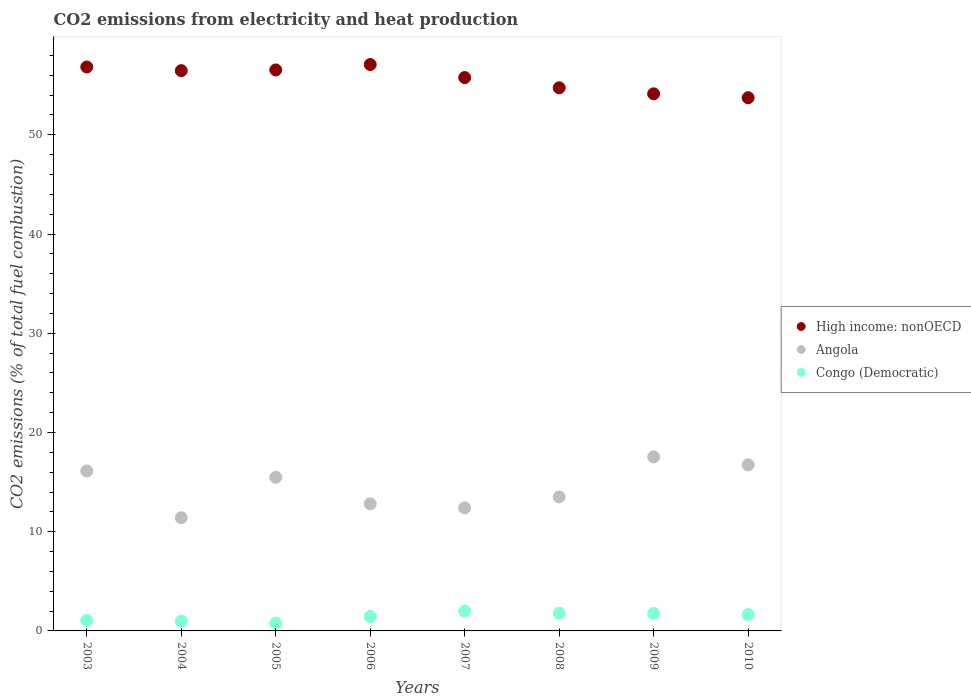How many different coloured dotlines are there?
Give a very brief answer. 3. What is the amount of CO2 emitted in Congo (Democratic) in 2007?
Make the answer very short. 1.99. Across all years, what is the maximum amount of CO2 emitted in High income: nonOECD?
Offer a very short reply. 57.08. Across all years, what is the minimum amount of CO2 emitted in High income: nonOECD?
Give a very brief answer. 53.74. In which year was the amount of CO2 emitted in Angola maximum?
Your response must be concise. 2009. In which year was the amount of CO2 emitted in Congo (Democratic) minimum?
Offer a terse response. 2005. What is the total amount of CO2 emitted in Congo (Democratic) in the graph?
Your response must be concise. 11.47. What is the difference between the amount of CO2 emitted in Angola in 2003 and that in 2009?
Keep it short and to the point. -1.42. What is the difference between the amount of CO2 emitted in Angola in 2006 and the amount of CO2 emitted in Congo (Democratic) in 2010?
Offer a very short reply. 11.17. What is the average amount of CO2 emitted in Angola per year?
Make the answer very short. 14.5. In the year 2009, what is the difference between the amount of CO2 emitted in High income: nonOECD and amount of CO2 emitted in Congo (Democratic)?
Offer a very short reply. 52.37. In how many years, is the amount of CO2 emitted in Angola greater than 22 %?
Offer a very short reply. 0. What is the ratio of the amount of CO2 emitted in Congo (Democratic) in 2006 to that in 2010?
Your answer should be compact. 0.89. What is the difference between the highest and the second highest amount of CO2 emitted in Congo (Democratic)?
Provide a succinct answer. 0.2. What is the difference between the highest and the lowest amount of CO2 emitted in Congo (Democratic)?
Ensure brevity in your answer.  1.21. In how many years, is the amount of CO2 emitted in Congo (Democratic) greater than the average amount of CO2 emitted in Congo (Democratic) taken over all years?
Ensure brevity in your answer.  5. Is it the case that in every year, the sum of the amount of CO2 emitted in High income: nonOECD and amount of CO2 emitted in Congo (Democratic)  is greater than the amount of CO2 emitted in Angola?
Give a very brief answer. Yes. Does the amount of CO2 emitted in Congo (Democratic) monotonically increase over the years?
Give a very brief answer. No. How many dotlines are there?
Ensure brevity in your answer.  3. How many years are there in the graph?
Give a very brief answer. 8. Are the values on the major ticks of Y-axis written in scientific E-notation?
Provide a succinct answer. No. Does the graph contain grids?
Your answer should be very brief. No. Where does the legend appear in the graph?
Your answer should be very brief. Center right. How many legend labels are there?
Make the answer very short. 3. How are the legend labels stacked?
Make the answer very short. Vertical. What is the title of the graph?
Keep it short and to the point. CO2 emissions from electricity and heat production. Does "Greenland" appear as one of the legend labels in the graph?
Offer a terse response. No. What is the label or title of the Y-axis?
Provide a succinct answer. CO2 emissions (% of total fuel combustion). What is the CO2 emissions (% of total fuel combustion) of High income: nonOECD in 2003?
Ensure brevity in your answer.  56.83. What is the CO2 emissions (% of total fuel combustion) of Angola in 2003?
Your answer should be very brief. 16.12. What is the CO2 emissions (% of total fuel combustion) of Congo (Democratic) in 2003?
Offer a terse response. 1.06. What is the CO2 emissions (% of total fuel combustion) in High income: nonOECD in 2004?
Keep it short and to the point. 56.46. What is the CO2 emissions (% of total fuel combustion) in Angola in 2004?
Your answer should be very brief. 11.41. What is the CO2 emissions (% of total fuel combustion) in Congo (Democratic) in 2004?
Give a very brief answer. 0.99. What is the CO2 emissions (% of total fuel combustion) in High income: nonOECD in 2005?
Offer a very short reply. 56.54. What is the CO2 emissions (% of total fuel combustion) of Angola in 2005?
Provide a short and direct response. 15.48. What is the CO2 emissions (% of total fuel combustion) in Congo (Democratic) in 2005?
Provide a succinct answer. 0.78. What is the CO2 emissions (% of total fuel combustion) of High income: nonOECD in 2006?
Provide a succinct answer. 57.08. What is the CO2 emissions (% of total fuel combustion) in Angola in 2006?
Ensure brevity in your answer.  12.81. What is the CO2 emissions (% of total fuel combustion) in Congo (Democratic) in 2006?
Ensure brevity in your answer.  1.46. What is the CO2 emissions (% of total fuel combustion) in High income: nonOECD in 2007?
Keep it short and to the point. 55.77. What is the CO2 emissions (% of total fuel combustion) in Angola in 2007?
Your answer should be compact. 12.4. What is the CO2 emissions (% of total fuel combustion) of Congo (Democratic) in 2007?
Your answer should be very brief. 1.99. What is the CO2 emissions (% of total fuel combustion) of High income: nonOECD in 2008?
Offer a very short reply. 54.74. What is the CO2 emissions (% of total fuel combustion) of Angola in 2008?
Offer a very short reply. 13.51. What is the CO2 emissions (% of total fuel combustion) in Congo (Democratic) in 2008?
Provide a short and direct response. 1.79. What is the CO2 emissions (% of total fuel combustion) in High income: nonOECD in 2009?
Offer a terse response. 54.13. What is the CO2 emissions (% of total fuel combustion) of Angola in 2009?
Offer a very short reply. 17.54. What is the CO2 emissions (% of total fuel combustion) of Congo (Democratic) in 2009?
Give a very brief answer. 1.76. What is the CO2 emissions (% of total fuel combustion) in High income: nonOECD in 2010?
Your answer should be very brief. 53.74. What is the CO2 emissions (% of total fuel combustion) of Angola in 2010?
Keep it short and to the point. 16.74. What is the CO2 emissions (% of total fuel combustion) in Congo (Democratic) in 2010?
Your response must be concise. 1.64. Across all years, what is the maximum CO2 emissions (% of total fuel combustion) of High income: nonOECD?
Provide a short and direct response. 57.08. Across all years, what is the maximum CO2 emissions (% of total fuel combustion) in Angola?
Provide a short and direct response. 17.54. Across all years, what is the maximum CO2 emissions (% of total fuel combustion) of Congo (Democratic)?
Your answer should be very brief. 1.99. Across all years, what is the minimum CO2 emissions (% of total fuel combustion) in High income: nonOECD?
Make the answer very short. 53.74. Across all years, what is the minimum CO2 emissions (% of total fuel combustion) of Angola?
Your response must be concise. 11.41. Across all years, what is the minimum CO2 emissions (% of total fuel combustion) in Congo (Democratic)?
Keep it short and to the point. 0.78. What is the total CO2 emissions (% of total fuel combustion) of High income: nonOECD in the graph?
Your answer should be compact. 445.29. What is the total CO2 emissions (% of total fuel combustion) in Angola in the graph?
Make the answer very short. 116.01. What is the total CO2 emissions (% of total fuel combustion) of Congo (Democratic) in the graph?
Your answer should be compact. 11.47. What is the difference between the CO2 emissions (% of total fuel combustion) in High income: nonOECD in 2003 and that in 2004?
Offer a terse response. 0.37. What is the difference between the CO2 emissions (% of total fuel combustion) of Angola in 2003 and that in 2004?
Offer a terse response. 4.71. What is the difference between the CO2 emissions (% of total fuel combustion) in Congo (Democratic) in 2003 and that in 2004?
Give a very brief answer. 0.07. What is the difference between the CO2 emissions (% of total fuel combustion) of High income: nonOECD in 2003 and that in 2005?
Ensure brevity in your answer.  0.3. What is the difference between the CO2 emissions (% of total fuel combustion) of Angola in 2003 and that in 2005?
Ensure brevity in your answer.  0.65. What is the difference between the CO2 emissions (% of total fuel combustion) of Congo (Democratic) in 2003 and that in 2005?
Your response must be concise. 0.28. What is the difference between the CO2 emissions (% of total fuel combustion) in High income: nonOECD in 2003 and that in 2006?
Ensure brevity in your answer.  -0.25. What is the difference between the CO2 emissions (% of total fuel combustion) of Angola in 2003 and that in 2006?
Provide a succinct answer. 3.32. What is the difference between the CO2 emissions (% of total fuel combustion) of Congo (Democratic) in 2003 and that in 2006?
Offer a very short reply. -0.4. What is the difference between the CO2 emissions (% of total fuel combustion) of High income: nonOECD in 2003 and that in 2007?
Make the answer very short. 1.06. What is the difference between the CO2 emissions (% of total fuel combustion) in Angola in 2003 and that in 2007?
Your answer should be compact. 3.73. What is the difference between the CO2 emissions (% of total fuel combustion) of Congo (Democratic) in 2003 and that in 2007?
Give a very brief answer. -0.92. What is the difference between the CO2 emissions (% of total fuel combustion) of High income: nonOECD in 2003 and that in 2008?
Offer a very short reply. 2.09. What is the difference between the CO2 emissions (% of total fuel combustion) of Angola in 2003 and that in 2008?
Offer a terse response. 2.62. What is the difference between the CO2 emissions (% of total fuel combustion) in Congo (Democratic) in 2003 and that in 2008?
Your answer should be compact. -0.72. What is the difference between the CO2 emissions (% of total fuel combustion) in High income: nonOECD in 2003 and that in 2009?
Make the answer very short. 2.7. What is the difference between the CO2 emissions (% of total fuel combustion) in Angola in 2003 and that in 2009?
Offer a very short reply. -1.42. What is the difference between the CO2 emissions (% of total fuel combustion) in Congo (Democratic) in 2003 and that in 2009?
Your answer should be compact. -0.7. What is the difference between the CO2 emissions (% of total fuel combustion) of High income: nonOECD in 2003 and that in 2010?
Keep it short and to the point. 3.1. What is the difference between the CO2 emissions (% of total fuel combustion) of Angola in 2003 and that in 2010?
Offer a terse response. -0.62. What is the difference between the CO2 emissions (% of total fuel combustion) of Congo (Democratic) in 2003 and that in 2010?
Your answer should be very brief. -0.58. What is the difference between the CO2 emissions (% of total fuel combustion) of High income: nonOECD in 2004 and that in 2005?
Ensure brevity in your answer.  -0.07. What is the difference between the CO2 emissions (% of total fuel combustion) in Angola in 2004 and that in 2005?
Your answer should be compact. -4.07. What is the difference between the CO2 emissions (% of total fuel combustion) in Congo (Democratic) in 2004 and that in 2005?
Your response must be concise. 0.21. What is the difference between the CO2 emissions (% of total fuel combustion) of High income: nonOECD in 2004 and that in 2006?
Your answer should be compact. -0.62. What is the difference between the CO2 emissions (% of total fuel combustion) in Angola in 2004 and that in 2006?
Keep it short and to the point. -1.4. What is the difference between the CO2 emissions (% of total fuel combustion) of Congo (Democratic) in 2004 and that in 2006?
Give a very brief answer. -0.47. What is the difference between the CO2 emissions (% of total fuel combustion) of High income: nonOECD in 2004 and that in 2007?
Give a very brief answer. 0.7. What is the difference between the CO2 emissions (% of total fuel combustion) in Angola in 2004 and that in 2007?
Offer a very short reply. -0.99. What is the difference between the CO2 emissions (% of total fuel combustion) of Congo (Democratic) in 2004 and that in 2007?
Keep it short and to the point. -1. What is the difference between the CO2 emissions (% of total fuel combustion) in High income: nonOECD in 2004 and that in 2008?
Make the answer very short. 1.73. What is the difference between the CO2 emissions (% of total fuel combustion) of Angola in 2004 and that in 2008?
Offer a very short reply. -2.1. What is the difference between the CO2 emissions (% of total fuel combustion) of Congo (Democratic) in 2004 and that in 2008?
Offer a very short reply. -0.8. What is the difference between the CO2 emissions (% of total fuel combustion) in High income: nonOECD in 2004 and that in 2009?
Provide a short and direct response. 2.33. What is the difference between the CO2 emissions (% of total fuel combustion) of Angola in 2004 and that in 2009?
Your answer should be very brief. -6.13. What is the difference between the CO2 emissions (% of total fuel combustion) of Congo (Democratic) in 2004 and that in 2009?
Provide a short and direct response. -0.77. What is the difference between the CO2 emissions (% of total fuel combustion) of High income: nonOECD in 2004 and that in 2010?
Offer a very short reply. 2.73. What is the difference between the CO2 emissions (% of total fuel combustion) of Angola in 2004 and that in 2010?
Keep it short and to the point. -5.33. What is the difference between the CO2 emissions (% of total fuel combustion) in Congo (Democratic) in 2004 and that in 2010?
Offer a very short reply. -0.65. What is the difference between the CO2 emissions (% of total fuel combustion) in High income: nonOECD in 2005 and that in 2006?
Provide a short and direct response. -0.55. What is the difference between the CO2 emissions (% of total fuel combustion) in Angola in 2005 and that in 2006?
Your response must be concise. 2.67. What is the difference between the CO2 emissions (% of total fuel combustion) of Congo (Democratic) in 2005 and that in 2006?
Your answer should be compact. -0.68. What is the difference between the CO2 emissions (% of total fuel combustion) of High income: nonOECD in 2005 and that in 2007?
Give a very brief answer. 0.77. What is the difference between the CO2 emissions (% of total fuel combustion) of Angola in 2005 and that in 2007?
Ensure brevity in your answer.  3.08. What is the difference between the CO2 emissions (% of total fuel combustion) of Congo (Democratic) in 2005 and that in 2007?
Provide a succinct answer. -1.21. What is the difference between the CO2 emissions (% of total fuel combustion) in High income: nonOECD in 2005 and that in 2008?
Your answer should be compact. 1.8. What is the difference between the CO2 emissions (% of total fuel combustion) of Angola in 2005 and that in 2008?
Ensure brevity in your answer.  1.97. What is the difference between the CO2 emissions (% of total fuel combustion) of Congo (Democratic) in 2005 and that in 2008?
Make the answer very short. -1. What is the difference between the CO2 emissions (% of total fuel combustion) in High income: nonOECD in 2005 and that in 2009?
Your response must be concise. 2.41. What is the difference between the CO2 emissions (% of total fuel combustion) of Angola in 2005 and that in 2009?
Give a very brief answer. -2.06. What is the difference between the CO2 emissions (% of total fuel combustion) of Congo (Democratic) in 2005 and that in 2009?
Your answer should be very brief. -0.98. What is the difference between the CO2 emissions (% of total fuel combustion) of High income: nonOECD in 2005 and that in 2010?
Keep it short and to the point. 2.8. What is the difference between the CO2 emissions (% of total fuel combustion) in Angola in 2005 and that in 2010?
Keep it short and to the point. -1.26. What is the difference between the CO2 emissions (% of total fuel combustion) of Congo (Democratic) in 2005 and that in 2010?
Offer a very short reply. -0.86. What is the difference between the CO2 emissions (% of total fuel combustion) in High income: nonOECD in 2006 and that in 2007?
Give a very brief answer. 1.31. What is the difference between the CO2 emissions (% of total fuel combustion) in Angola in 2006 and that in 2007?
Make the answer very short. 0.41. What is the difference between the CO2 emissions (% of total fuel combustion) of Congo (Democratic) in 2006 and that in 2007?
Your answer should be compact. -0.53. What is the difference between the CO2 emissions (% of total fuel combustion) in High income: nonOECD in 2006 and that in 2008?
Your answer should be very brief. 2.34. What is the difference between the CO2 emissions (% of total fuel combustion) in Angola in 2006 and that in 2008?
Offer a terse response. -0.7. What is the difference between the CO2 emissions (% of total fuel combustion) in Congo (Democratic) in 2006 and that in 2008?
Give a very brief answer. -0.33. What is the difference between the CO2 emissions (% of total fuel combustion) of High income: nonOECD in 2006 and that in 2009?
Give a very brief answer. 2.95. What is the difference between the CO2 emissions (% of total fuel combustion) in Angola in 2006 and that in 2009?
Your answer should be very brief. -4.73. What is the difference between the CO2 emissions (% of total fuel combustion) in Congo (Democratic) in 2006 and that in 2009?
Offer a very short reply. -0.3. What is the difference between the CO2 emissions (% of total fuel combustion) of High income: nonOECD in 2006 and that in 2010?
Ensure brevity in your answer.  3.35. What is the difference between the CO2 emissions (% of total fuel combustion) of Angola in 2006 and that in 2010?
Offer a very short reply. -3.93. What is the difference between the CO2 emissions (% of total fuel combustion) of Congo (Democratic) in 2006 and that in 2010?
Offer a terse response. -0.18. What is the difference between the CO2 emissions (% of total fuel combustion) in Angola in 2007 and that in 2008?
Offer a very short reply. -1.11. What is the difference between the CO2 emissions (% of total fuel combustion) of Congo (Democratic) in 2007 and that in 2008?
Offer a very short reply. 0.2. What is the difference between the CO2 emissions (% of total fuel combustion) of High income: nonOECD in 2007 and that in 2009?
Provide a succinct answer. 1.64. What is the difference between the CO2 emissions (% of total fuel combustion) in Angola in 2007 and that in 2009?
Make the answer very short. -5.15. What is the difference between the CO2 emissions (% of total fuel combustion) in Congo (Democratic) in 2007 and that in 2009?
Make the answer very short. 0.22. What is the difference between the CO2 emissions (% of total fuel combustion) in High income: nonOECD in 2007 and that in 2010?
Ensure brevity in your answer.  2.03. What is the difference between the CO2 emissions (% of total fuel combustion) in Angola in 2007 and that in 2010?
Your answer should be very brief. -4.34. What is the difference between the CO2 emissions (% of total fuel combustion) of Congo (Democratic) in 2007 and that in 2010?
Ensure brevity in your answer.  0.35. What is the difference between the CO2 emissions (% of total fuel combustion) of High income: nonOECD in 2008 and that in 2009?
Your answer should be very brief. 0.61. What is the difference between the CO2 emissions (% of total fuel combustion) of Angola in 2008 and that in 2009?
Offer a terse response. -4.04. What is the difference between the CO2 emissions (% of total fuel combustion) of Congo (Democratic) in 2008 and that in 2009?
Provide a succinct answer. 0.02. What is the difference between the CO2 emissions (% of total fuel combustion) in High income: nonOECD in 2008 and that in 2010?
Provide a succinct answer. 1. What is the difference between the CO2 emissions (% of total fuel combustion) in Angola in 2008 and that in 2010?
Offer a terse response. -3.23. What is the difference between the CO2 emissions (% of total fuel combustion) of Congo (Democratic) in 2008 and that in 2010?
Your answer should be very brief. 0.15. What is the difference between the CO2 emissions (% of total fuel combustion) of High income: nonOECD in 2009 and that in 2010?
Offer a very short reply. 0.39. What is the difference between the CO2 emissions (% of total fuel combustion) in Angola in 2009 and that in 2010?
Offer a terse response. 0.8. What is the difference between the CO2 emissions (% of total fuel combustion) in Congo (Democratic) in 2009 and that in 2010?
Provide a short and direct response. 0.13. What is the difference between the CO2 emissions (% of total fuel combustion) in High income: nonOECD in 2003 and the CO2 emissions (% of total fuel combustion) in Angola in 2004?
Offer a very short reply. 45.42. What is the difference between the CO2 emissions (% of total fuel combustion) of High income: nonOECD in 2003 and the CO2 emissions (% of total fuel combustion) of Congo (Democratic) in 2004?
Your response must be concise. 55.84. What is the difference between the CO2 emissions (% of total fuel combustion) in Angola in 2003 and the CO2 emissions (% of total fuel combustion) in Congo (Democratic) in 2004?
Provide a short and direct response. 15.13. What is the difference between the CO2 emissions (% of total fuel combustion) in High income: nonOECD in 2003 and the CO2 emissions (% of total fuel combustion) in Angola in 2005?
Keep it short and to the point. 41.35. What is the difference between the CO2 emissions (% of total fuel combustion) of High income: nonOECD in 2003 and the CO2 emissions (% of total fuel combustion) of Congo (Democratic) in 2005?
Keep it short and to the point. 56.05. What is the difference between the CO2 emissions (% of total fuel combustion) of Angola in 2003 and the CO2 emissions (% of total fuel combustion) of Congo (Democratic) in 2005?
Your answer should be very brief. 15.34. What is the difference between the CO2 emissions (% of total fuel combustion) of High income: nonOECD in 2003 and the CO2 emissions (% of total fuel combustion) of Angola in 2006?
Give a very brief answer. 44.02. What is the difference between the CO2 emissions (% of total fuel combustion) in High income: nonOECD in 2003 and the CO2 emissions (% of total fuel combustion) in Congo (Democratic) in 2006?
Provide a succinct answer. 55.37. What is the difference between the CO2 emissions (% of total fuel combustion) of Angola in 2003 and the CO2 emissions (% of total fuel combustion) of Congo (Democratic) in 2006?
Your answer should be very brief. 14.66. What is the difference between the CO2 emissions (% of total fuel combustion) of High income: nonOECD in 2003 and the CO2 emissions (% of total fuel combustion) of Angola in 2007?
Provide a short and direct response. 44.44. What is the difference between the CO2 emissions (% of total fuel combustion) of High income: nonOECD in 2003 and the CO2 emissions (% of total fuel combustion) of Congo (Democratic) in 2007?
Offer a terse response. 54.85. What is the difference between the CO2 emissions (% of total fuel combustion) in Angola in 2003 and the CO2 emissions (% of total fuel combustion) in Congo (Democratic) in 2007?
Offer a very short reply. 14.14. What is the difference between the CO2 emissions (% of total fuel combustion) in High income: nonOECD in 2003 and the CO2 emissions (% of total fuel combustion) in Angola in 2008?
Give a very brief answer. 43.33. What is the difference between the CO2 emissions (% of total fuel combustion) in High income: nonOECD in 2003 and the CO2 emissions (% of total fuel combustion) in Congo (Democratic) in 2008?
Make the answer very short. 55.05. What is the difference between the CO2 emissions (% of total fuel combustion) of Angola in 2003 and the CO2 emissions (% of total fuel combustion) of Congo (Democratic) in 2008?
Give a very brief answer. 14.34. What is the difference between the CO2 emissions (% of total fuel combustion) in High income: nonOECD in 2003 and the CO2 emissions (% of total fuel combustion) in Angola in 2009?
Provide a succinct answer. 39.29. What is the difference between the CO2 emissions (% of total fuel combustion) in High income: nonOECD in 2003 and the CO2 emissions (% of total fuel combustion) in Congo (Democratic) in 2009?
Make the answer very short. 55.07. What is the difference between the CO2 emissions (% of total fuel combustion) in Angola in 2003 and the CO2 emissions (% of total fuel combustion) in Congo (Democratic) in 2009?
Give a very brief answer. 14.36. What is the difference between the CO2 emissions (% of total fuel combustion) of High income: nonOECD in 2003 and the CO2 emissions (% of total fuel combustion) of Angola in 2010?
Ensure brevity in your answer.  40.09. What is the difference between the CO2 emissions (% of total fuel combustion) of High income: nonOECD in 2003 and the CO2 emissions (% of total fuel combustion) of Congo (Democratic) in 2010?
Provide a short and direct response. 55.19. What is the difference between the CO2 emissions (% of total fuel combustion) of Angola in 2003 and the CO2 emissions (% of total fuel combustion) of Congo (Democratic) in 2010?
Offer a very short reply. 14.49. What is the difference between the CO2 emissions (% of total fuel combustion) of High income: nonOECD in 2004 and the CO2 emissions (% of total fuel combustion) of Angola in 2005?
Keep it short and to the point. 40.98. What is the difference between the CO2 emissions (% of total fuel combustion) of High income: nonOECD in 2004 and the CO2 emissions (% of total fuel combustion) of Congo (Democratic) in 2005?
Provide a short and direct response. 55.68. What is the difference between the CO2 emissions (% of total fuel combustion) of Angola in 2004 and the CO2 emissions (% of total fuel combustion) of Congo (Democratic) in 2005?
Your answer should be compact. 10.63. What is the difference between the CO2 emissions (% of total fuel combustion) in High income: nonOECD in 2004 and the CO2 emissions (% of total fuel combustion) in Angola in 2006?
Your answer should be very brief. 43.66. What is the difference between the CO2 emissions (% of total fuel combustion) of High income: nonOECD in 2004 and the CO2 emissions (% of total fuel combustion) of Congo (Democratic) in 2006?
Your response must be concise. 55. What is the difference between the CO2 emissions (% of total fuel combustion) in Angola in 2004 and the CO2 emissions (% of total fuel combustion) in Congo (Democratic) in 2006?
Ensure brevity in your answer.  9.95. What is the difference between the CO2 emissions (% of total fuel combustion) of High income: nonOECD in 2004 and the CO2 emissions (% of total fuel combustion) of Angola in 2007?
Give a very brief answer. 44.07. What is the difference between the CO2 emissions (% of total fuel combustion) of High income: nonOECD in 2004 and the CO2 emissions (% of total fuel combustion) of Congo (Democratic) in 2007?
Keep it short and to the point. 54.48. What is the difference between the CO2 emissions (% of total fuel combustion) in Angola in 2004 and the CO2 emissions (% of total fuel combustion) in Congo (Democratic) in 2007?
Provide a short and direct response. 9.42. What is the difference between the CO2 emissions (% of total fuel combustion) of High income: nonOECD in 2004 and the CO2 emissions (% of total fuel combustion) of Angola in 2008?
Provide a succinct answer. 42.96. What is the difference between the CO2 emissions (% of total fuel combustion) of High income: nonOECD in 2004 and the CO2 emissions (% of total fuel combustion) of Congo (Democratic) in 2008?
Your response must be concise. 54.68. What is the difference between the CO2 emissions (% of total fuel combustion) in Angola in 2004 and the CO2 emissions (% of total fuel combustion) in Congo (Democratic) in 2008?
Offer a terse response. 9.62. What is the difference between the CO2 emissions (% of total fuel combustion) in High income: nonOECD in 2004 and the CO2 emissions (% of total fuel combustion) in Angola in 2009?
Offer a very short reply. 38.92. What is the difference between the CO2 emissions (% of total fuel combustion) of High income: nonOECD in 2004 and the CO2 emissions (% of total fuel combustion) of Congo (Democratic) in 2009?
Provide a short and direct response. 54.7. What is the difference between the CO2 emissions (% of total fuel combustion) of Angola in 2004 and the CO2 emissions (% of total fuel combustion) of Congo (Democratic) in 2009?
Provide a succinct answer. 9.65. What is the difference between the CO2 emissions (% of total fuel combustion) in High income: nonOECD in 2004 and the CO2 emissions (% of total fuel combustion) in Angola in 2010?
Give a very brief answer. 39.72. What is the difference between the CO2 emissions (% of total fuel combustion) of High income: nonOECD in 2004 and the CO2 emissions (% of total fuel combustion) of Congo (Democratic) in 2010?
Provide a short and direct response. 54.82. What is the difference between the CO2 emissions (% of total fuel combustion) of Angola in 2004 and the CO2 emissions (% of total fuel combustion) of Congo (Democratic) in 2010?
Offer a very short reply. 9.77. What is the difference between the CO2 emissions (% of total fuel combustion) in High income: nonOECD in 2005 and the CO2 emissions (% of total fuel combustion) in Angola in 2006?
Give a very brief answer. 43.73. What is the difference between the CO2 emissions (% of total fuel combustion) of High income: nonOECD in 2005 and the CO2 emissions (% of total fuel combustion) of Congo (Democratic) in 2006?
Give a very brief answer. 55.08. What is the difference between the CO2 emissions (% of total fuel combustion) in Angola in 2005 and the CO2 emissions (% of total fuel combustion) in Congo (Democratic) in 2006?
Make the answer very short. 14.02. What is the difference between the CO2 emissions (% of total fuel combustion) of High income: nonOECD in 2005 and the CO2 emissions (% of total fuel combustion) of Angola in 2007?
Your answer should be compact. 44.14. What is the difference between the CO2 emissions (% of total fuel combustion) in High income: nonOECD in 2005 and the CO2 emissions (% of total fuel combustion) in Congo (Democratic) in 2007?
Your answer should be very brief. 54.55. What is the difference between the CO2 emissions (% of total fuel combustion) in Angola in 2005 and the CO2 emissions (% of total fuel combustion) in Congo (Democratic) in 2007?
Offer a terse response. 13.49. What is the difference between the CO2 emissions (% of total fuel combustion) of High income: nonOECD in 2005 and the CO2 emissions (% of total fuel combustion) of Angola in 2008?
Provide a short and direct response. 43.03. What is the difference between the CO2 emissions (% of total fuel combustion) in High income: nonOECD in 2005 and the CO2 emissions (% of total fuel combustion) in Congo (Democratic) in 2008?
Offer a terse response. 54.75. What is the difference between the CO2 emissions (% of total fuel combustion) of Angola in 2005 and the CO2 emissions (% of total fuel combustion) of Congo (Democratic) in 2008?
Provide a succinct answer. 13.69. What is the difference between the CO2 emissions (% of total fuel combustion) of High income: nonOECD in 2005 and the CO2 emissions (% of total fuel combustion) of Angola in 2009?
Provide a short and direct response. 38.99. What is the difference between the CO2 emissions (% of total fuel combustion) in High income: nonOECD in 2005 and the CO2 emissions (% of total fuel combustion) in Congo (Democratic) in 2009?
Give a very brief answer. 54.77. What is the difference between the CO2 emissions (% of total fuel combustion) in Angola in 2005 and the CO2 emissions (% of total fuel combustion) in Congo (Democratic) in 2009?
Give a very brief answer. 13.72. What is the difference between the CO2 emissions (% of total fuel combustion) of High income: nonOECD in 2005 and the CO2 emissions (% of total fuel combustion) of Angola in 2010?
Ensure brevity in your answer.  39.8. What is the difference between the CO2 emissions (% of total fuel combustion) of High income: nonOECD in 2005 and the CO2 emissions (% of total fuel combustion) of Congo (Democratic) in 2010?
Your response must be concise. 54.9. What is the difference between the CO2 emissions (% of total fuel combustion) in Angola in 2005 and the CO2 emissions (% of total fuel combustion) in Congo (Democratic) in 2010?
Your answer should be very brief. 13.84. What is the difference between the CO2 emissions (% of total fuel combustion) in High income: nonOECD in 2006 and the CO2 emissions (% of total fuel combustion) in Angola in 2007?
Offer a terse response. 44.69. What is the difference between the CO2 emissions (% of total fuel combustion) in High income: nonOECD in 2006 and the CO2 emissions (% of total fuel combustion) in Congo (Democratic) in 2007?
Offer a terse response. 55.1. What is the difference between the CO2 emissions (% of total fuel combustion) of Angola in 2006 and the CO2 emissions (% of total fuel combustion) of Congo (Democratic) in 2007?
Your response must be concise. 10.82. What is the difference between the CO2 emissions (% of total fuel combustion) in High income: nonOECD in 2006 and the CO2 emissions (% of total fuel combustion) in Angola in 2008?
Keep it short and to the point. 43.58. What is the difference between the CO2 emissions (% of total fuel combustion) in High income: nonOECD in 2006 and the CO2 emissions (% of total fuel combustion) in Congo (Democratic) in 2008?
Your answer should be compact. 55.3. What is the difference between the CO2 emissions (% of total fuel combustion) of Angola in 2006 and the CO2 emissions (% of total fuel combustion) of Congo (Democratic) in 2008?
Give a very brief answer. 11.02. What is the difference between the CO2 emissions (% of total fuel combustion) in High income: nonOECD in 2006 and the CO2 emissions (% of total fuel combustion) in Angola in 2009?
Provide a short and direct response. 39.54. What is the difference between the CO2 emissions (% of total fuel combustion) in High income: nonOECD in 2006 and the CO2 emissions (% of total fuel combustion) in Congo (Democratic) in 2009?
Provide a short and direct response. 55.32. What is the difference between the CO2 emissions (% of total fuel combustion) in Angola in 2006 and the CO2 emissions (% of total fuel combustion) in Congo (Democratic) in 2009?
Keep it short and to the point. 11.04. What is the difference between the CO2 emissions (% of total fuel combustion) of High income: nonOECD in 2006 and the CO2 emissions (% of total fuel combustion) of Angola in 2010?
Give a very brief answer. 40.34. What is the difference between the CO2 emissions (% of total fuel combustion) of High income: nonOECD in 2006 and the CO2 emissions (% of total fuel combustion) of Congo (Democratic) in 2010?
Offer a very short reply. 55.44. What is the difference between the CO2 emissions (% of total fuel combustion) of Angola in 2006 and the CO2 emissions (% of total fuel combustion) of Congo (Democratic) in 2010?
Make the answer very short. 11.17. What is the difference between the CO2 emissions (% of total fuel combustion) of High income: nonOECD in 2007 and the CO2 emissions (% of total fuel combustion) of Angola in 2008?
Ensure brevity in your answer.  42.26. What is the difference between the CO2 emissions (% of total fuel combustion) of High income: nonOECD in 2007 and the CO2 emissions (% of total fuel combustion) of Congo (Democratic) in 2008?
Your response must be concise. 53.98. What is the difference between the CO2 emissions (% of total fuel combustion) of Angola in 2007 and the CO2 emissions (% of total fuel combustion) of Congo (Democratic) in 2008?
Give a very brief answer. 10.61. What is the difference between the CO2 emissions (% of total fuel combustion) of High income: nonOECD in 2007 and the CO2 emissions (% of total fuel combustion) of Angola in 2009?
Ensure brevity in your answer.  38.23. What is the difference between the CO2 emissions (% of total fuel combustion) of High income: nonOECD in 2007 and the CO2 emissions (% of total fuel combustion) of Congo (Democratic) in 2009?
Your response must be concise. 54. What is the difference between the CO2 emissions (% of total fuel combustion) of Angola in 2007 and the CO2 emissions (% of total fuel combustion) of Congo (Democratic) in 2009?
Give a very brief answer. 10.63. What is the difference between the CO2 emissions (% of total fuel combustion) of High income: nonOECD in 2007 and the CO2 emissions (% of total fuel combustion) of Angola in 2010?
Make the answer very short. 39.03. What is the difference between the CO2 emissions (% of total fuel combustion) in High income: nonOECD in 2007 and the CO2 emissions (% of total fuel combustion) in Congo (Democratic) in 2010?
Keep it short and to the point. 54.13. What is the difference between the CO2 emissions (% of total fuel combustion) of Angola in 2007 and the CO2 emissions (% of total fuel combustion) of Congo (Democratic) in 2010?
Offer a very short reply. 10.76. What is the difference between the CO2 emissions (% of total fuel combustion) of High income: nonOECD in 2008 and the CO2 emissions (% of total fuel combustion) of Angola in 2009?
Your response must be concise. 37.2. What is the difference between the CO2 emissions (% of total fuel combustion) of High income: nonOECD in 2008 and the CO2 emissions (% of total fuel combustion) of Congo (Democratic) in 2009?
Your answer should be compact. 52.97. What is the difference between the CO2 emissions (% of total fuel combustion) in Angola in 2008 and the CO2 emissions (% of total fuel combustion) in Congo (Democratic) in 2009?
Your answer should be very brief. 11.74. What is the difference between the CO2 emissions (% of total fuel combustion) of High income: nonOECD in 2008 and the CO2 emissions (% of total fuel combustion) of Angola in 2010?
Make the answer very short. 38. What is the difference between the CO2 emissions (% of total fuel combustion) of High income: nonOECD in 2008 and the CO2 emissions (% of total fuel combustion) of Congo (Democratic) in 2010?
Ensure brevity in your answer.  53.1. What is the difference between the CO2 emissions (% of total fuel combustion) in Angola in 2008 and the CO2 emissions (% of total fuel combustion) in Congo (Democratic) in 2010?
Provide a succinct answer. 11.87. What is the difference between the CO2 emissions (% of total fuel combustion) in High income: nonOECD in 2009 and the CO2 emissions (% of total fuel combustion) in Angola in 2010?
Provide a succinct answer. 37.39. What is the difference between the CO2 emissions (% of total fuel combustion) of High income: nonOECD in 2009 and the CO2 emissions (% of total fuel combustion) of Congo (Democratic) in 2010?
Keep it short and to the point. 52.49. What is the difference between the CO2 emissions (% of total fuel combustion) of Angola in 2009 and the CO2 emissions (% of total fuel combustion) of Congo (Democratic) in 2010?
Keep it short and to the point. 15.9. What is the average CO2 emissions (% of total fuel combustion) in High income: nonOECD per year?
Provide a short and direct response. 55.66. What is the average CO2 emissions (% of total fuel combustion) of Angola per year?
Keep it short and to the point. 14.5. What is the average CO2 emissions (% of total fuel combustion) of Congo (Democratic) per year?
Keep it short and to the point. 1.43. In the year 2003, what is the difference between the CO2 emissions (% of total fuel combustion) of High income: nonOECD and CO2 emissions (% of total fuel combustion) of Angola?
Give a very brief answer. 40.71. In the year 2003, what is the difference between the CO2 emissions (% of total fuel combustion) of High income: nonOECD and CO2 emissions (% of total fuel combustion) of Congo (Democratic)?
Give a very brief answer. 55.77. In the year 2003, what is the difference between the CO2 emissions (% of total fuel combustion) of Angola and CO2 emissions (% of total fuel combustion) of Congo (Democratic)?
Ensure brevity in your answer.  15.06. In the year 2004, what is the difference between the CO2 emissions (% of total fuel combustion) of High income: nonOECD and CO2 emissions (% of total fuel combustion) of Angola?
Offer a very short reply. 45.05. In the year 2004, what is the difference between the CO2 emissions (% of total fuel combustion) of High income: nonOECD and CO2 emissions (% of total fuel combustion) of Congo (Democratic)?
Provide a short and direct response. 55.47. In the year 2004, what is the difference between the CO2 emissions (% of total fuel combustion) of Angola and CO2 emissions (% of total fuel combustion) of Congo (Democratic)?
Ensure brevity in your answer.  10.42. In the year 2005, what is the difference between the CO2 emissions (% of total fuel combustion) in High income: nonOECD and CO2 emissions (% of total fuel combustion) in Angola?
Provide a short and direct response. 41.06. In the year 2005, what is the difference between the CO2 emissions (% of total fuel combustion) in High income: nonOECD and CO2 emissions (% of total fuel combustion) in Congo (Democratic)?
Offer a very short reply. 55.76. In the year 2005, what is the difference between the CO2 emissions (% of total fuel combustion) of Angola and CO2 emissions (% of total fuel combustion) of Congo (Democratic)?
Your answer should be very brief. 14.7. In the year 2006, what is the difference between the CO2 emissions (% of total fuel combustion) of High income: nonOECD and CO2 emissions (% of total fuel combustion) of Angola?
Ensure brevity in your answer.  44.27. In the year 2006, what is the difference between the CO2 emissions (% of total fuel combustion) of High income: nonOECD and CO2 emissions (% of total fuel combustion) of Congo (Democratic)?
Your answer should be very brief. 55.62. In the year 2006, what is the difference between the CO2 emissions (% of total fuel combustion) in Angola and CO2 emissions (% of total fuel combustion) in Congo (Democratic)?
Provide a short and direct response. 11.35. In the year 2007, what is the difference between the CO2 emissions (% of total fuel combustion) of High income: nonOECD and CO2 emissions (% of total fuel combustion) of Angola?
Your answer should be compact. 43.37. In the year 2007, what is the difference between the CO2 emissions (% of total fuel combustion) in High income: nonOECD and CO2 emissions (% of total fuel combustion) in Congo (Democratic)?
Provide a succinct answer. 53.78. In the year 2007, what is the difference between the CO2 emissions (% of total fuel combustion) of Angola and CO2 emissions (% of total fuel combustion) of Congo (Democratic)?
Offer a terse response. 10.41. In the year 2008, what is the difference between the CO2 emissions (% of total fuel combustion) of High income: nonOECD and CO2 emissions (% of total fuel combustion) of Angola?
Make the answer very short. 41.23. In the year 2008, what is the difference between the CO2 emissions (% of total fuel combustion) in High income: nonOECD and CO2 emissions (% of total fuel combustion) in Congo (Democratic)?
Provide a short and direct response. 52.95. In the year 2008, what is the difference between the CO2 emissions (% of total fuel combustion) of Angola and CO2 emissions (% of total fuel combustion) of Congo (Democratic)?
Offer a very short reply. 11.72. In the year 2009, what is the difference between the CO2 emissions (% of total fuel combustion) of High income: nonOECD and CO2 emissions (% of total fuel combustion) of Angola?
Keep it short and to the point. 36.59. In the year 2009, what is the difference between the CO2 emissions (% of total fuel combustion) of High income: nonOECD and CO2 emissions (% of total fuel combustion) of Congo (Democratic)?
Keep it short and to the point. 52.37. In the year 2009, what is the difference between the CO2 emissions (% of total fuel combustion) in Angola and CO2 emissions (% of total fuel combustion) in Congo (Democratic)?
Give a very brief answer. 15.78. In the year 2010, what is the difference between the CO2 emissions (% of total fuel combustion) of High income: nonOECD and CO2 emissions (% of total fuel combustion) of Angola?
Your response must be concise. 36.99. In the year 2010, what is the difference between the CO2 emissions (% of total fuel combustion) in High income: nonOECD and CO2 emissions (% of total fuel combustion) in Congo (Democratic)?
Your response must be concise. 52.1. In the year 2010, what is the difference between the CO2 emissions (% of total fuel combustion) in Angola and CO2 emissions (% of total fuel combustion) in Congo (Democratic)?
Offer a very short reply. 15.1. What is the ratio of the CO2 emissions (% of total fuel combustion) in Angola in 2003 to that in 2004?
Provide a succinct answer. 1.41. What is the ratio of the CO2 emissions (% of total fuel combustion) of Congo (Democratic) in 2003 to that in 2004?
Make the answer very short. 1.07. What is the ratio of the CO2 emissions (% of total fuel combustion) of Angola in 2003 to that in 2005?
Keep it short and to the point. 1.04. What is the ratio of the CO2 emissions (% of total fuel combustion) in Congo (Democratic) in 2003 to that in 2005?
Provide a succinct answer. 1.36. What is the ratio of the CO2 emissions (% of total fuel combustion) of Angola in 2003 to that in 2006?
Provide a succinct answer. 1.26. What is the ratio of the CO2 emissions (% of total fuel combustion) in Congo (Democratic) in 2003 to that in 2006?
Keep it short and to the point. 0.73. What is the ratio of the CO2 emissions (% of total fuel combustion) in High income: nonOECD in 2003 to that in 2007?
Offer a terse response. 1.02. What is the ratio of the CO2 emissions (% of total fuel combustion) of Angola in 2003 to that in 2007?
Provide a short and direct response. 1.3. What is the ratio of the CO2 emissions (% of total fuel combustion) in Congo (Democratic) in 2003 to that in 2007?
Provide a succinct answer. 0.54. What is the ratio of the CO2 emissions (% of total fuel combustion) of High income: nonOECD in 2003 to that in 2008?
Provide a succinct answer. 1.04. What is the ratio of the CO2 emissions (% of total fuel combustion) of Angola in 2003 to that in 2008?
Give a very brief answer. 1.19. What is the ratio of the CO2 emissions (% of total fuel combustion) in Congo (Democratic) in 2003 to that in 2008?
Provide a short and direct response. 0.6. What is the ratio of the CO2 emissions (% of total fuel combustion) of High income: nonOECD in 2003 to that in 2009?
Your response must be concise. 1.05. What is the ratio of the CO2 emissions (% of total fuel combustion) of Angola in 2003 to that in 2009?
Ensure brevity in your answer.  0.92. What is the ratio of the CO2 emissions (% of total fuel combustion) of Congo (Democratic) in 2003 to that in 2009?
Make the answer very short. 0.6. What is the ratio of the CO2 emissions (% of total fuel combustion) of High income: nonOECD in 2003 to that in 2010?
Your answer should be very brief. 1.06. What is the ratio of the CO2 emissions (% of total fuel combustion) of Angola in 2003 to that in 2010?
Offer a very short reply. 0.96. What is the ratio of the CO2 emissions (% of total fuel combustion) of Congo (Democratic) in 2003 to that in 2010?
Offer a very short reply. 0.65. What is the ratio of the CO2 emissions (% of total fuel combustion) in High income: nonOECD in 2004 to that in 2005?
Provide a short and direct response. 1. What is the ratio of the CO2 emissions (% of total fuel combustion) in Angola in 2004 to that in 2005?
Make the answer very short. 0.74. What is the ratio of the CO2 emissions (% of total fuel combustion) in Congo (Democratic) in 2004 to that in 2005?
Provide a short and direct response. 1.27. What is the ratio of the CO2 emissions (% of total fuel combustion) of Angola in 2004 to that in 2006?
Provide a short and direct response. 0.89. What is the ratio of the CO2 emissions (% of total fuel combustion) in Congo (Democratic) in 2004 to that in 2006?
Your answer should be compact. 0.68. What is the ratio of the CO2 emissions (% of total fuel combustion) in High income: nonOECD in 2004 to that in 2007?
Ensure brevity in your answer.  1.01. What is the ratio of the CO2 emissions (% of total fuel combustion) of Angola in 2004 to that in 2007?
Provide a short and direct response. 0.92. What is the ratio of the CO2 emissions (% of total fuel combustion) in Congo (Democratic) in 2004 to that in 2007?
Provide a short and direct response. 0.5. What is the ratio of the CO2 emissions (% of total fuel combustion) in High income: nonOECD in 2004 to that in 2008?
Your answer should be very brief. 1.03. What is the ratio of the CO2 emissions (% of total fuel combustion) in Angola in 2004 to that in 2008?
Your response must be concise. 0.84. What is the ratio of the CO2 emissions (% of total fuel combustion) of Congo (Democratic) in 2004 to that in 2008?
Provide a short and direct response. 0.55. What is the ratio of the CO2 emissions (% of total fuel combustion) in High income: nonOECD in 2004 to that in 2009?
Your response must be concise. 1.04. What is the ratio of the CO2 emissions (% of total fuel combustion) in Angola in 2004 to that in 2009?
Provide a succinct answer. 0.65. What is the ratio of the CO2 emissions (% of total fuel combustion) of Congo (Democratic) in 2004 to that in 2009?
Provide a succinct answer. 0.56. What is the ratio of the CO2 emissions (% of total fuel combustion) in High income: nonOECD in 2004 to that in 2010?
Your answer should be very brief. 1.05. What is the ratio of the CO2 emissions (% of total fuel combustion) in Angola in 2004 to that in 2010?
Your response must be concise. 0.68. What is the ratio of the CO2 emissions (% of total fuel combustion) in Congo (Democratic) in 2004 to that in 2010?
Give a very brief answer. 0.6. What is the ratio of the CO2 emissions (% of total fuel combustion) in Angola in 2005 to that in 2006?
Offer a terse response. 1.21. What is the ratio of the CO2 emissions (% of total fuel combustion) in Congo (Democratic) in 2005 to that in 2006?
Your answer should be compact. 0.54. What is the ratio of the CO2 emissions (% of total fuel combustion) in High income: nonOECD in 2005 to that in 2007?
Your answer should be compact. 1.01. What is the ratio of the CO2 emissions (% of total fuel combustion) of Angola in 2005 to that in 2007?
Your answer should be compact. 1.25. What is the ratio of the CO2 emissions (% of total fuel combustion) in Congo (Democratic) in 2005 to that in 2007?
Ensure brevity in your answer.  0.39. What is the ratio of the CO2 emissions (% of total fuel combustion) of High income: nonOECD in 2005 to that in 2008?
Give a very brief answer. 1.03. What is the ratio of the CO2 emissions (% of total fuel combustion) of Angola in 2005 to that in 2008?
Keep it short and to the point. 1.15. What is the ratio of the CO2 emissions (% of total fuel combustion) of Congo (Democratic) in 2005 to that in 2008?
Give a very brief answer. 0.44. What is the ratio of the CO2 emissions (% of total fuel combustion) in High income: nonOECD in 2005 to that in 2009?
Your response must be concise. 1.04. What is the ratio of the CO2 emissions (% of total fuel combustion) of Angola in 2005 to that in 2009?
Your answer should be compact. 0.88. What is the ratio of the CO2 emissions (% of total fuel combustion) in Congo (Democratic) in 2005 to that in 2009?
Provide a succinct answer. 0.44. What is the ratio of the CO2 emissions (% of total fuel combustion) in High income: nonOECD in 2005 to that in 2010?
Keep it short and to the point. 1.05. What is the ratio of the CO2 emissions (% of total fuel combustion) of Angola in 2005 to that in 2010?
Provide a succinct answer. 0.92. What is the ratio of the CO2 emissions (% of total fuel combustion) of Congo (Democratic) in 2005 to that in 2010?
Your answer should be compact. 0.48. What is the ratio of the CO2 emissions (% of total fuel combustion) of High income: nonOECD in 2006 to that in 2007?
Your response must be concise. 1.02. What is the ratio of the CO2 emissions (% of total fuel combustion) of Angola in 2006 to that in 2007?
Make the answer very short. 1.03. What is the ratio of the CO2 emissions (% of total fuel combustion) in Congo (Democratic) in 2006 to that in 2007?
Offer a very short reply. 0.73. What is the ratio of the CO2 emissions (% of total fuel combustion) in High income: nonOECD in 2006 to that in 2008?
Keep it short and to the point. 1.04. What is the ratio of the CO2 emissions (% of total fuel combustion) of Angola in 2006 to that in 2008?
Offer a terse response. 0.95. What is the ratio of the CO2 emissions (% of total fuel combustion) in Congo (Democratic) in 2006 to that in 2008?
Provide a succinct answer. 0.82. What is the ratio of the CO2 emissions (% of total fuel combustion) in High income: nonOECD in 2006 to that in 2009?
Offer a terse response. 1.05. What is the ratio of the CO2 emissions (% of total fuel combustion) in Angola in 2006 to that in 2009?
Your answer should be very brief. 0.73. What is the ratio of the CO2 emissions (% of total fuel combustion) in Congo (Democratic) in 2006 to that in 2009?
Provide a succinct answer. 0.83. What is the ratio of the CO2 emissions (% of total fuel combustion) of High income: nonOECD in 2006 to that in 2010?
Keep it short and to the point. 1.06. What is the ratio of the CO2 emissions (% of total fuel combustion) in Angola in 2006 to that in 2010?
Your answer should be compact. 0.77. What is the ratio of the CO2 emissions (% of total fuel combustion) in Congo (Democratic) in 2006 to that in 2010?
Ensure brevity in your answer.  0.89. What is the ratio of the CO2 emissions (% of total fuel combustion) of High income: nonOECD in 2007 to that in 2008?
Make the answer very short. 1.02. What is the ratio of the CO2 emissions (% of total fuel combustion) in Angola in 2007 to that in 2008?
Provide a short and direct response. 0.92. What is the ratio of the CO2 emissions (% of total fuel combustion) in Congo (Democratic) in 2007 to that in 2008?
Make the answer very short. 1.11. What is the ratio of the CO2 emissions (% of total fuel combustion) of High income: nonOECD in 2007 to that in 2009?
Make the answer very short. 1.03. What is the ratio of the CO2 emissions (% of total fuel combustion) in Angola in 2007 to that in 2009?
Your answer should be compact. 0.71. What is the ratio of the CO2 emissions (% of total fuel combustion) of Congo (Democratic) in 2007 to that in 2009?
Offer a very short reply. 1.13. What is the ratio of the CO2 emissions (% of total fuel combustion) in High income: nonOECD in 2007 to that in 2010?
Your answer should be very brief. 1.04. What is the ratio of the CO2 emissions (% of total fuel combustion) in Angola in 2007 to that in 2010?
Your response must be concise. 0.74. What is the ratio of the CO2 emissions (% of total fuel combustion) in Congo (Democratic) in 2007 to that in 2010?
Keep it short and to the point. 1.21. What is the ratio of the CO2 emissions (% of total fuel combustion) in High income: nonOECD in 2008 to that in 2009?
Ensure brevity in your answer.  1.01. What is the ratio of the CO2 emissions (% of total fuel combustion) of Angola in 2008 to that in 2009?
Provide a short and direct response. 0.77. What is the ratio of the CO2 emissions (% of total fuel combustion) in Congo (Democratic) in 2008 to that in 2009?
Your response must be concise. 1.01. What is the ratio of the CO2 emissions (% of total fuel combustion) in High income: nonOECD in 2008 to that in 2010?
Keep it short and to the point. 1.02. What is the ratio of the CO2 emissions (% of total fuel combustion) in Angola in 2008 to that in 2010?
Give a very brief answer. 0.81. What is the ratio of the CO2 emissions (% of total fuel combustion) of Congo (Democratic) in 2008 to that in 2010?
Make the answer very short. 1.09. What is the ratio of the CO2 emissions (% of total fuel combustion) in High income: nonOECD in 2009 to that in 2010?
Provide a succinct answer. 1.01. What is the ratio of the CO2 emissions (% of total fuel combustion) in Angola in 2009 to that in 2010?
Provide a short and direct response. 1.05. What is the ratio of the CO2 emissions (% of total fuel combustion) in Congo (Democratic) in 2009 to that in 2010?
Provide a succinct answer. 1.08. What is the difference between the highest and the second highest CO2 emissions (% of total fuel combustion) in High income: nonOECD?
Provide a short and direct response. 0.25. What is the difference between the highest and the second highest CO2 emissions (% of total fuel combustion) of Angola?
Your answer should be very brief. 0.8. What is the difference between the highest and the second highest CO2 emissions (% of total fuel combustion) of Congo (Democratic)?
Provide a short and direct response. 0.2. What is the difference between the highest and the lowest CO2 emissions (% of total fuel combustion) of High income: nonOECD?
Offer a very short reply. 3.35. What is the difference between the highest and the lowest CO2 emissions (% of total fuel combustion) of Angola?
Offer a very short reply. 6.13. What is the difference between the highest and the lowest CO2 emissions (% of total fuel combustion) of Congo (Democratic)?
Your response must be concise. 1.21. 